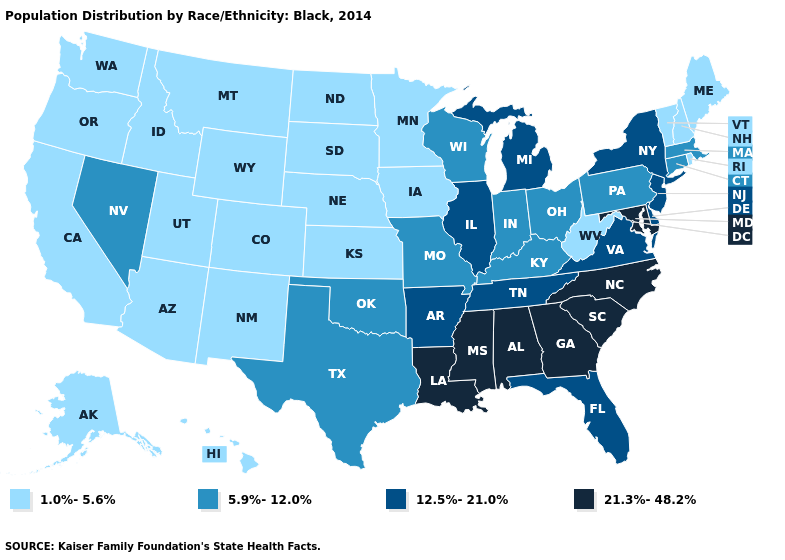Does Maryland have the highest value in the South?
Quick response, please. Yes. Among the states that border Iowa , which have the lowest value?
Answer briefly. Minnesota, Nebraska, South Dakota. What is the value of Wisconsin?
Short answer required. 5.9%-12.0%. Which states have the lowest value in the USA?
Give a very brief answer. Alaska, Arizona, California, Colorado, Hawaii, Idaho, Iowa, Kansas, Maine, Minnesota, Montana, Nebraska, New Hampshire, New Mexico, North Dakota, Oregon, Rhode Island, South Dakota, Utah, Vermont, Washington, West Virginia, Wyoming. Among the states that border Texas , does Oklahoma have the lowest value?
Answer briefly. No. Name the states that have a value in the range 12.5%-21.0%?
Keep it brief. Arkansas, Delaware, Florida, Illinois, Michigan, New Jersey, New York, Tennessee, Virginia. What is the value of Louisiana?
Quick response, please. 21.3%-48.2%. What is the value of Arizona?
Keep it brief. 1.0%-5.6%. What is the value of Kentucky?
Concise answer only. 5.9%-12.0%. Among the states that border Louisiana , does Arkansas have the highest value?
Keep it brief. No. Is the legend a continuous bar?
Keep it brief. No. Does the first symbol in the legend represent the smallest category?
Quick response, please. Yes. Name the states that have a value in the range 5.9%-12.0%?
Write a very short answer. Connecticut, Indiana, Kentucky, Massachusetts, Missouri, Nevada, Ohio, Oklahoma, Pennsylvania, Texas, Wisconsin. What is the value of North Carolina?
Short answer required. 21.3%-48.2%. Which states have the lowest value in the USA?
Quick response, please. Alaska, Arizona, California, Colorado, Hawaii, Idaho, Iowa, Kansas, Maine, Minnesota, Montana, Nebraska, New Hampshire, New Mexico, North Dakota, Oregon, Rhode Island, South Dakota, Utah, Vermont, Washington, West Virginia, Wyoming. 